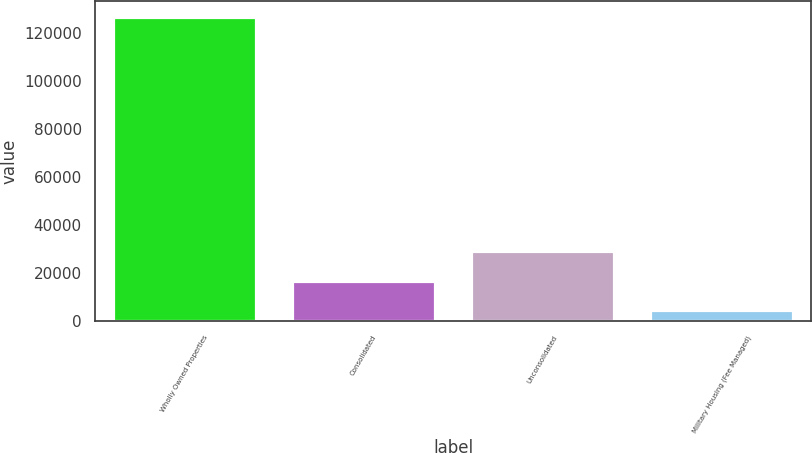Convert chart. <chart><loc_0><loc_0><loc_500><loc_500><bar_chart><fcel>Wholly Owned Properties<fcel>Consolidated<fcel>Unconsolidated<fcel>Military Housing (Fee Managed)<nl><fcel>127002<fcel>16938.3<fcel>29167.6<fcel>4709<nl></chart> 